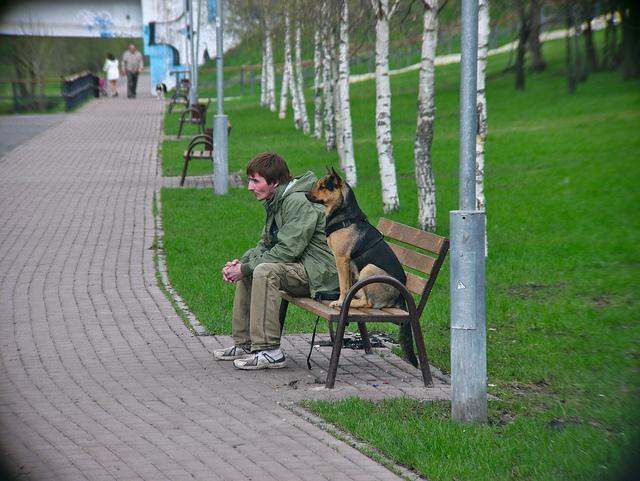How many people are shown?
Give a very brief answer. 3. How many dogs are shown?
Give a very brief answer. 1. 